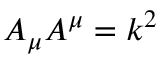Convert formula to latex. <formula><loc_0><loc_0><loc_500><loc_500>A _ { \mu } A ^ { \mu } = k ^ { 2 }</formula> 